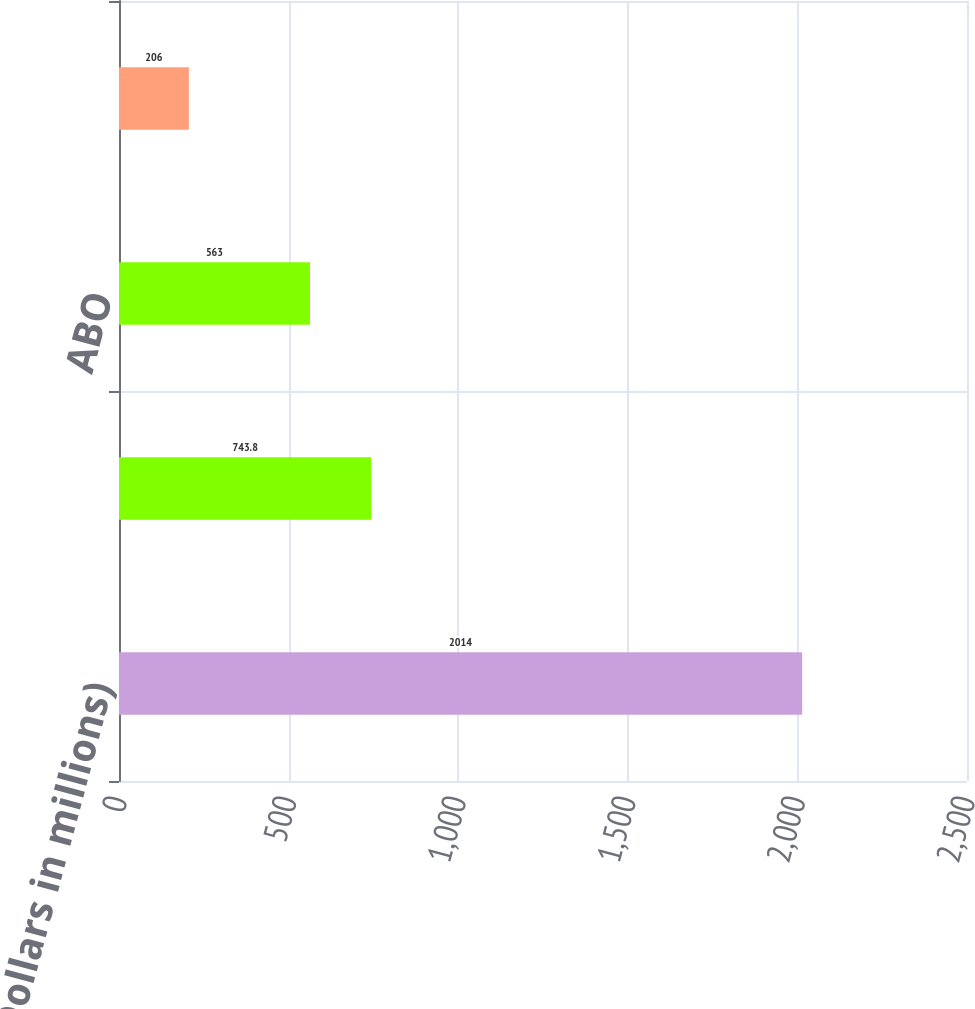Convert chart to OTSL. <chart><loc_0><loc_0><loc_500><loc_500><bar_chart><fcel>(Dollars in millions)<fcel>PBO<fcel>ABO<fcel>Fair value of plan assets<nl><fcel>2014<fcel>743.8<fcel>563<fcel>206<nl></chart> 